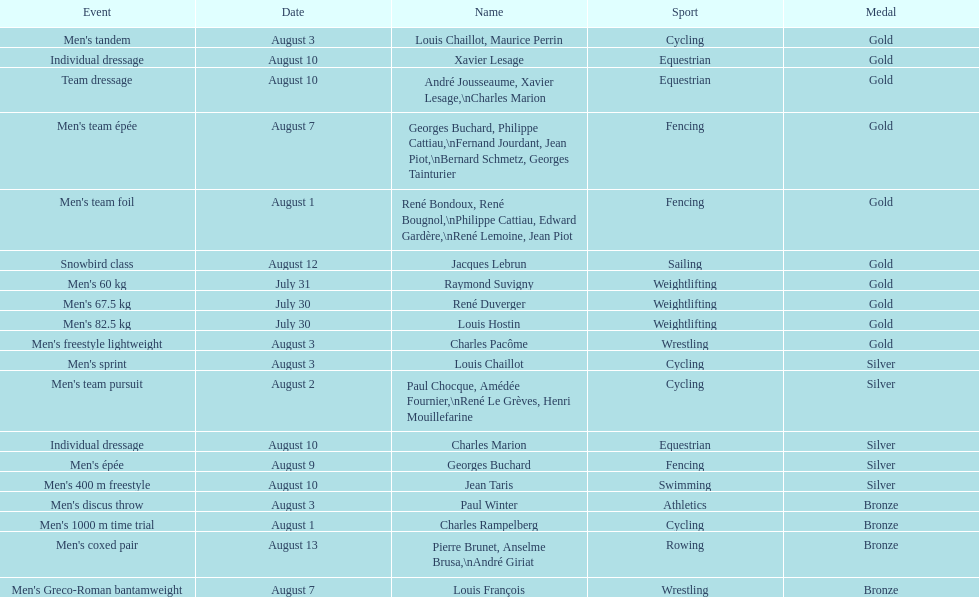Louis chaillot won a gold medal for cycling and a silver medal for what sport? Cycling. 